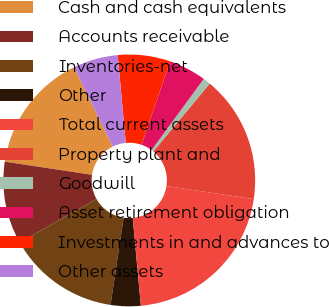Convert chart. <chart><loc_0><loc_0><loc_500><loc_500><pie_chart><fcel>Cash and cash equivalents<fcel>Accounts receivable<fcel>Inventories-net<fcel>Other<fcel>Total current assets<fcel>Property plant and<fcel>Goodwill<fcel>Asset retirement obligation<fcel>Investments in and advances to<fcel>Other assets<nl><fcel>15.38%<fcel>10.58%<fcel>14.42%<fcel>3.85%<fcel>21.15%<fcel>16.34%<fcel>0.96%<fcel>4.81%<fcel>6.73%<fcel>5.77%<nl></chart> 